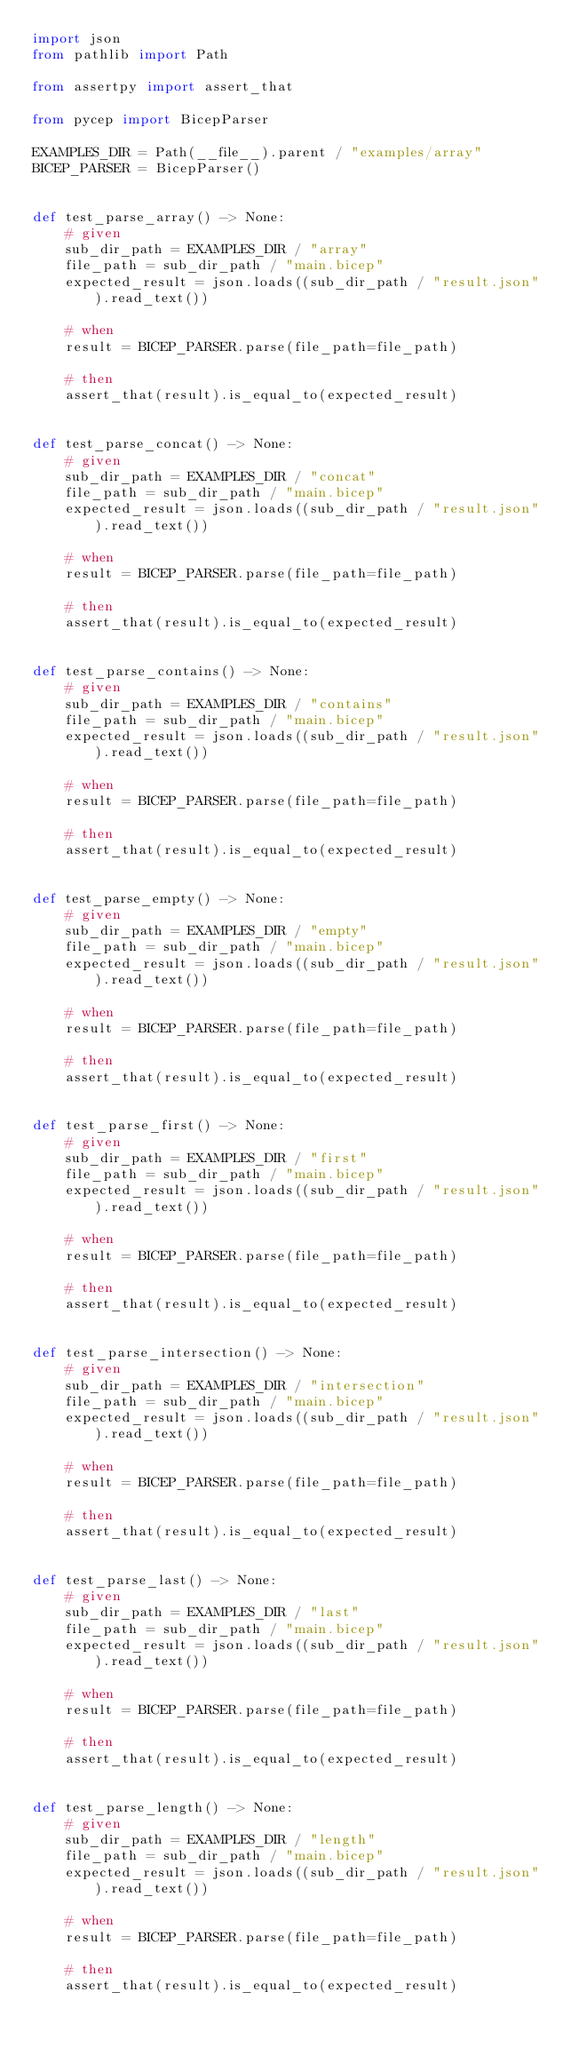<code> <loc_0><loc_0><loc_500><loc_500><_Python_>import json
from pathlib import Path

from assertpy import assert_that

from pycep import BicepParser

EXAMPLES_DIR = Path(__file__).parent / "examples/array"
BICEP_PARSER = BicepParser()


def test_parse_array() -> None:
    # given
    sub_dir_path = EXAMPLES_DIR / "array"
    file_path = sub_dir_path / "main.bicep"
    expected_result = json.loads((sub_dir_path / "result.json").read_text())

    # when
    result = BICEP_PARSER.parse(file_path=file_path)

    # then
    assert_that(result).is_equal_to(expected_result)


def test_parse_concat() -> None:
    # given
    sub_dir_path = EXAMPLES_DIR / "concat"
    file_path = sub_dir_path / "main.bicep"
    expected_result = json.loads((sub_dir_path / "result.json").read_text())

    # when
    result = BICEP_PARSER.parse(file_path=file_path)

    # then
    assert_that(result).is_equal_to(expected_result)


def test_parse_contains() -> None:
    # given
    sub_dir_path = EXAMPLES_DIR / "contains"
    file_path = sub_dir_path / "main.bicep"
    expected_result = json.loads((sub_dir_path / "result.json").read_text())

    # when
    result = BICEP_PARSER.parse(file_path=file_path)

    # then
    assert_that(result).is_equal_to(expected_result)


def test_parse_empty() -> None:
    # given
    sub_dir_path = EXAMPLES_DIR / "empty"
    file_path = sub_dir_path / "main.bicep"
    expected_result = json.loads((sub_dir_path / "result.json").read_text())

    # when
    result = BICEP_PARSER.parse(file_path=file_path)

    # then
    assert_that(result).is_equal_to(expected_result)


def test_parse_first() -> None:
    # given
    sub_dir_path = EXAMPLES_DIR / "first"
    file_path = sub_dir_path / "main.bicep"
    expected_result = json.loads((sub_dir_path / "result.json").read_text())

    # when
    result = BICEP_PARSER.parse(file_path=file_path)

    # then
    assert_that(result).is_equal_to(expected_result)


def test_parse_intersection() -> None:
    # given
    sub_dir_path = EXAMPLES_DIR / "intersection"
    file_path = sub_dir_path / "main.bicep"
    expected_result = json.loads((sub_dir_path / "result.json").read_text())

    # when
    result = BICEP_PARSER.parse(file_path=file_path)

    # then
    assert_that(result).is_equal_to(expected_result)


def test_parse_last() -> None:
    # given
    sub_dir_path = EXAMPLES_DIR / "last"
    file_path = sub_dir_path / "main.bicep"
    expected_result = json.loads((sub_dir_path / "result.json").read_text())

    # when
    result = BICEP_PARSER.parse(file_path=file_path)

    # then
    assert_that(result).is_equal_to(expected_result)


def test_parse_length() -> None:
    # given
    sub_dir_path = EXAMPLES_DIR / "length"
    file_path = sub_dir_path / "main.bicep"
    expected_result = json.loads((sub_dir_path / "result.json").read_text())

    # when
    result = BICEP_PARSER.parse(file_path=file_path)

    # then
    assert_that(result).is_equal_to(expected_result)

</code> 